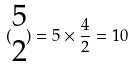<formula> <loc_0><loc_0><loc_500><loc_500>( \begin{matrix} 5 \\ 2 \end{matrix} ) = 5 \times \frac { 4 } { 2 } = 1 0</formula> 